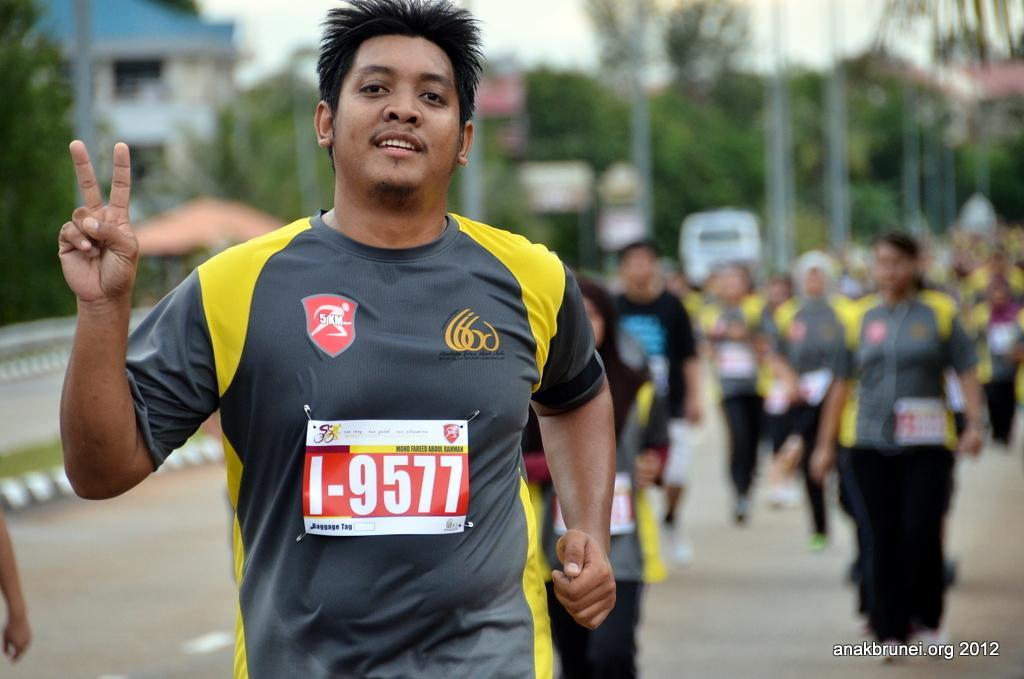Describe this image in one or two sentences. In the middle of the image there is a man with grey and yellow t-shirt. There is a poster on him. Behind him at the right side there are few people are on the road. There is a blur background with trees, poles and also there is a building with roof. 